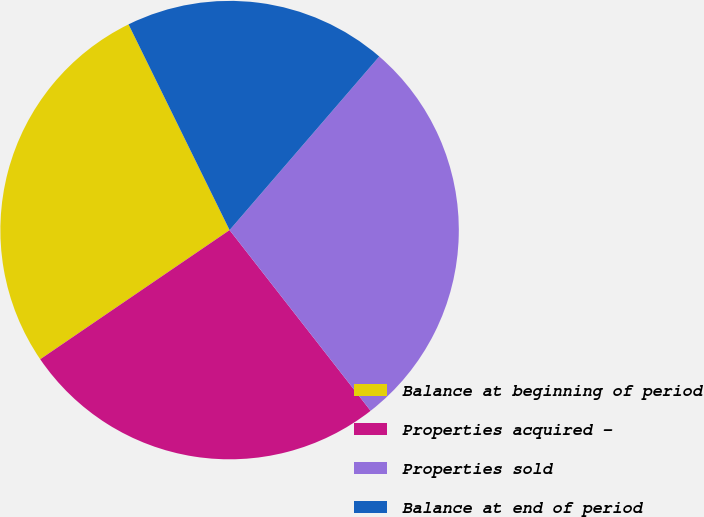Convert chart. <chart><loc_0><loc_0><loc_500><loc_500><pie_chart><fcel>Balance at beginning of period<fcel>Properties acquired -<fcel>Properties sold<fcel>Balance at end of period<nl><fcel>27.26%<fcel>26.02%<fcel>28.13%<fcel>18.59%<nl></chart> 